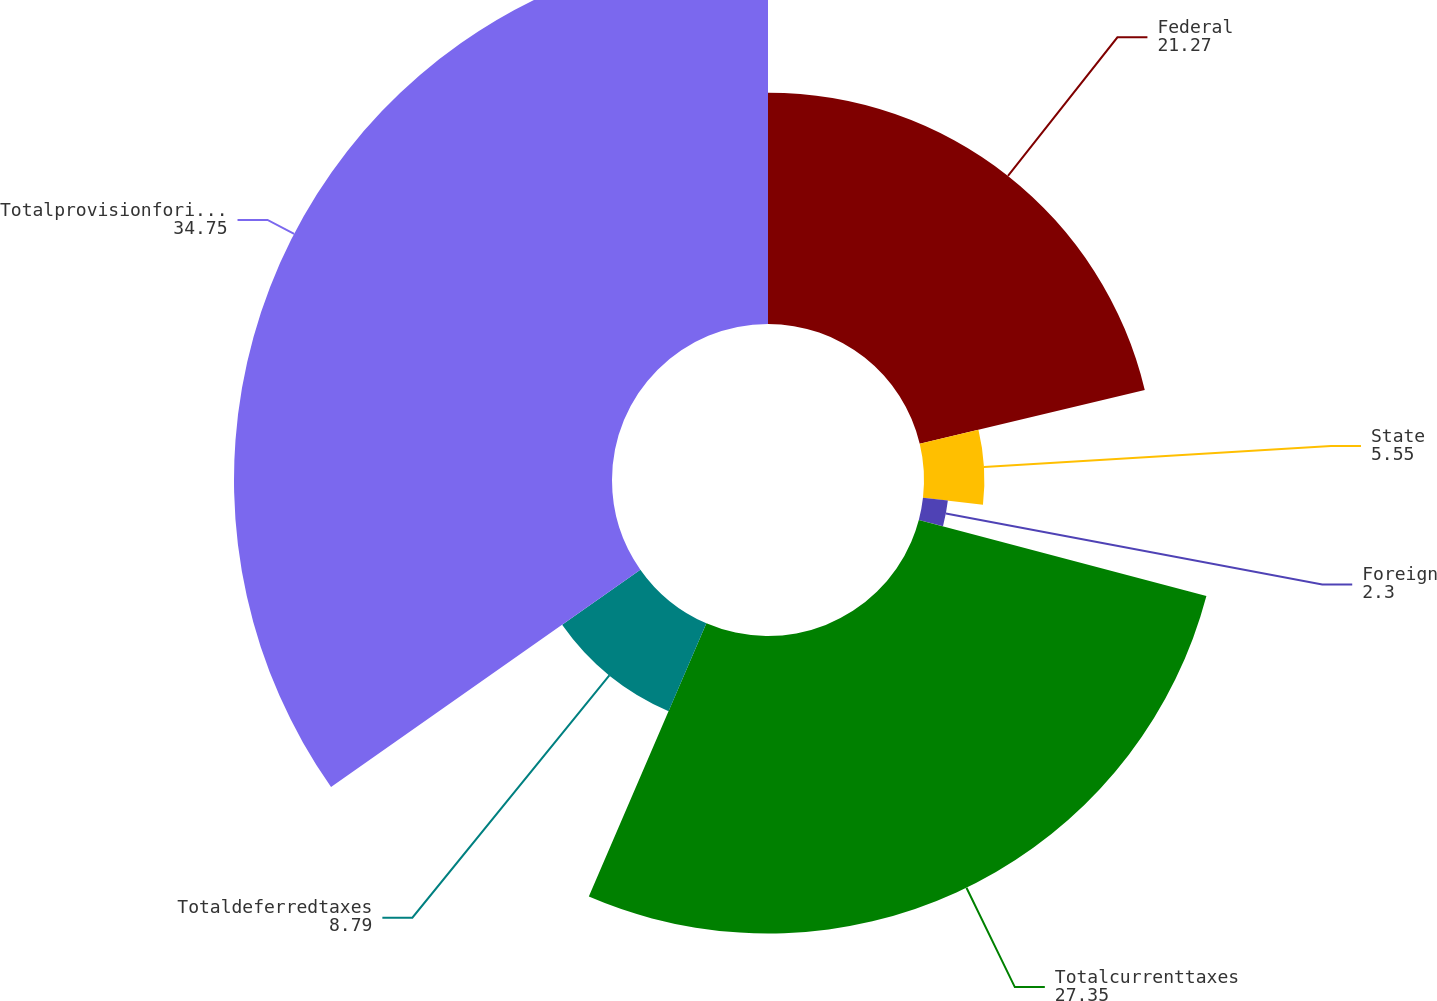Convert chart to OTSL. <chart><loc_0><loc_0><loc_500><loc_500><pie_chart><fcel>Federal<fcel>State<fcel>Foreign<fcel>Totalcurrenttaxes<fcel>Totaldeferredtaxes<fcel>Totalprovisionforincometaxes<nl><fcel>21.27%<fcel>5.55%<fcel>2.3%<fcel>27.35%<fcel>8.79%<fcel>34.75%<nl></chart> 